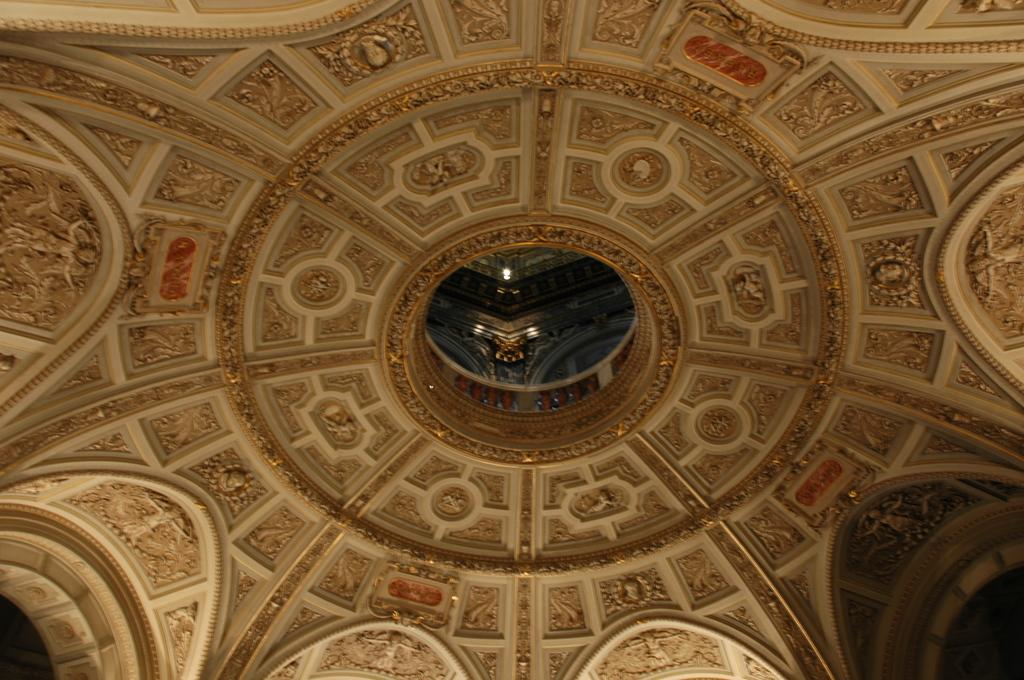What is present on top of the structure in the image? There is a roof in the image. What can be observed on the roof in the image? The roof has many carvings and sculptures. What type of clam can be seen opening its mouth in the image? There is no clam present in the image, and therefore no such activity can be observed. 